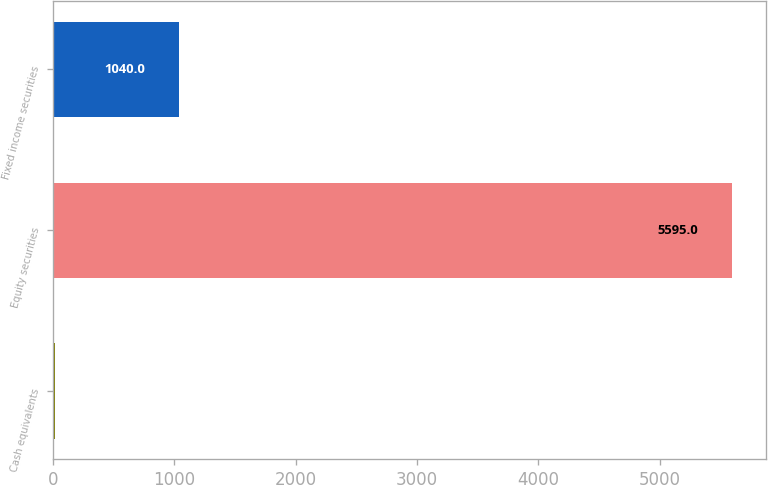Convert chart. <chart><loc_0><loc_0><loc_500><loc_500><bar_chart><fcel>Cash equivalents<fcel>Equity securities<fcel>Fixed income securities<nl><fcel>20<fcel>5595<fcel>1040<nl></chart> 